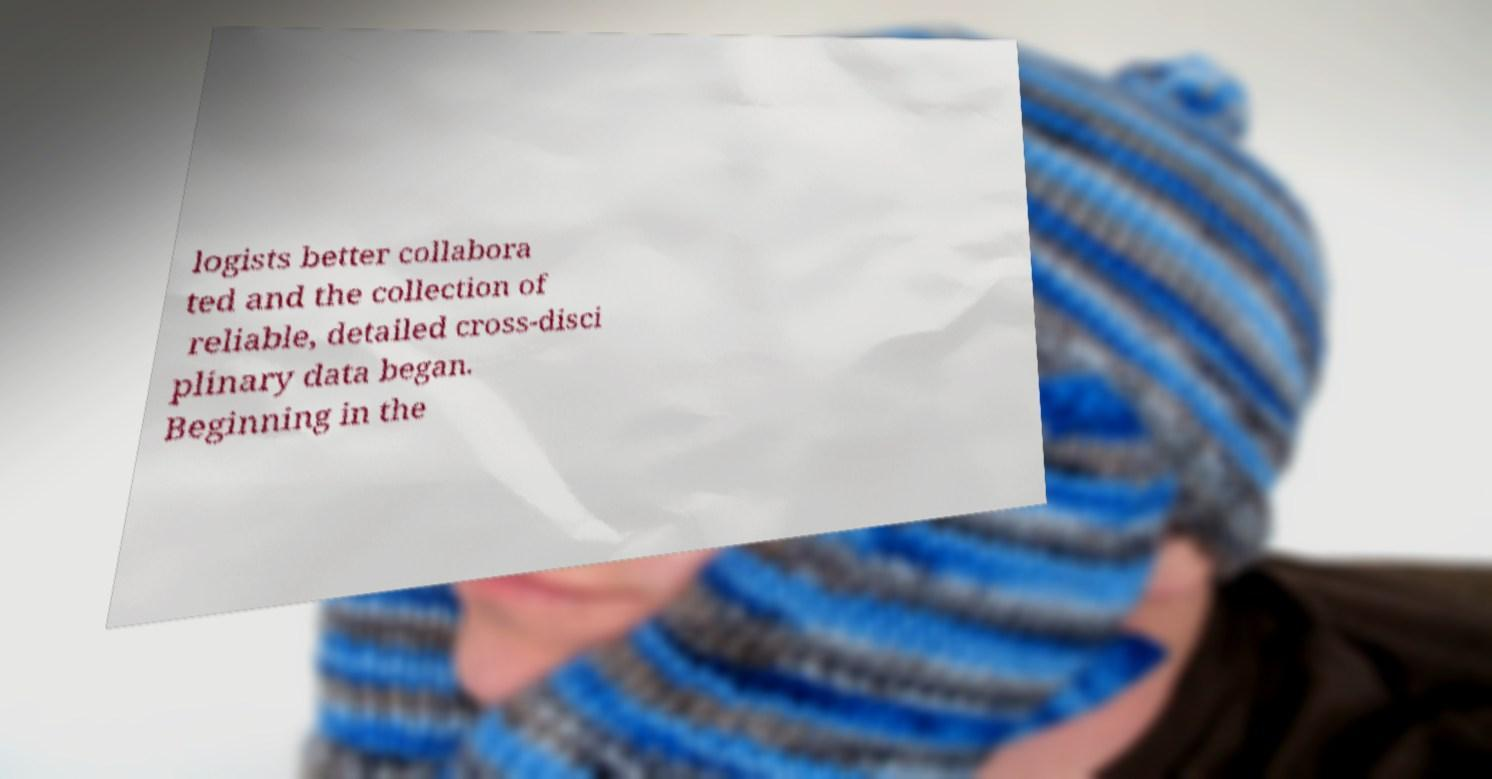Please read and relay the text visible in this image. What does it say? logists better collabora ted and the collection of reliable, detailed cross-disci plinary data began. Beginning in the 